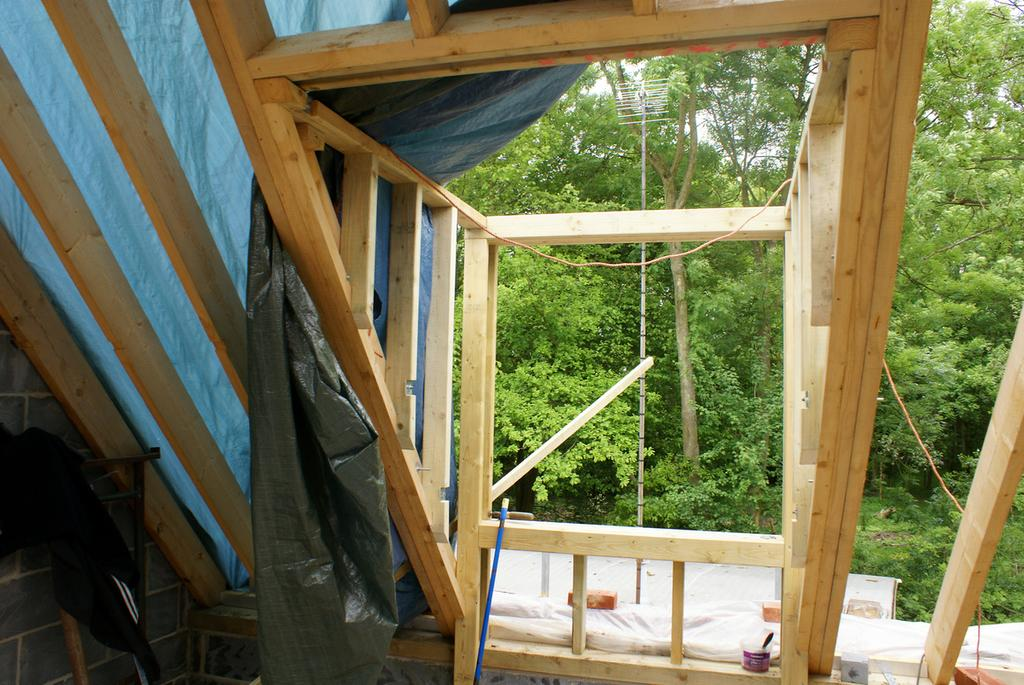What type of objects are made of wood and visible in the image? There are wooden sticks in the image. What type of natural vegetation can be seen in the image? There are trees visible in the image. What type of rail can be seen in the image? There is no rail present in the image. Is there a cook preparing food in the image? There is no cook or food preparation visible in the image. 